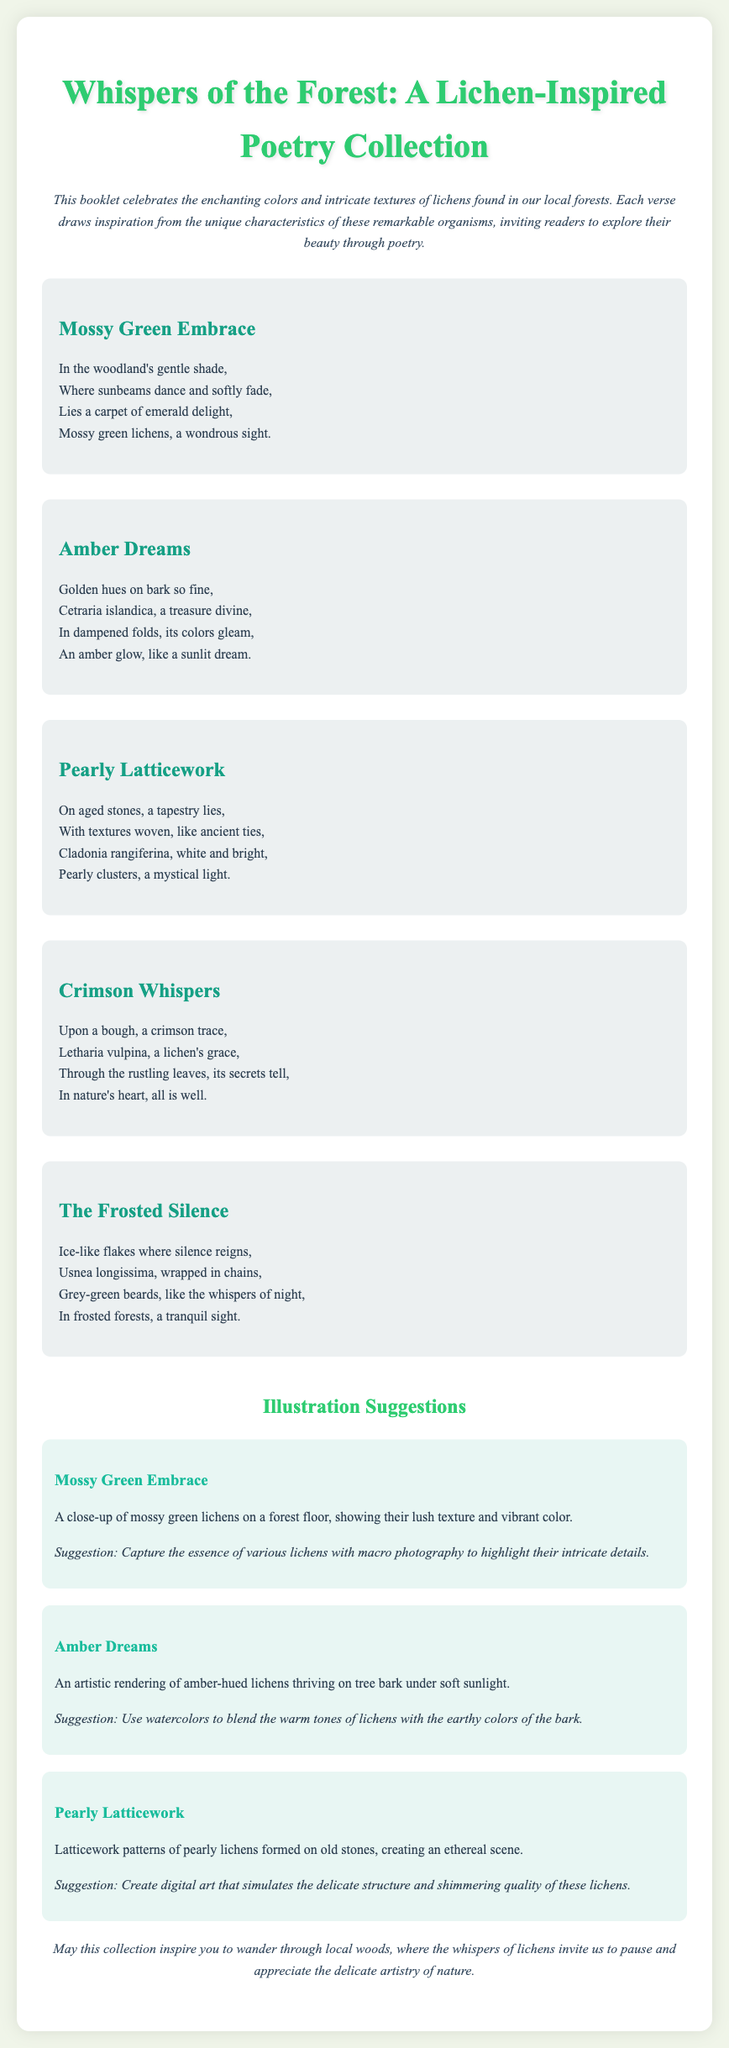What is the title of the poetry collection? The title of the poetry collection is clearly stated at the top of the document.
Answer: Whispers of the Forest: A Lichen-Inspired Poetry Collection How many poems are included in the collection? The total number of poems can be counted in the document under the poems section.
Answer: Five Which lichen is described in "Amber Dreams"? The specific lichen mentioned in the poem "Amber Dreams" is identified in the text.
Answer: Cetraria islandica What color are the lichens in "Crimson Whispers"? The color of the lichens described in "Crimson Whispers" is indicated in the poem.
Answer: Crimson What art style is suggested for the illustration of "Amber Dreams"? The suggested art style for the illustration of "Amber Dreams" is mentioned in the corresponding section.
Answer: Watercolors What is the main theme of the collection? The main theme is discussed in the introductory paragraph which conveys the essence of the document.
Answer: Colors and textures of lichens Who is the intended audience for this poetry collection? The intended audience can be inferred from the content and structure of the document.
Answer: Nature lovers and poetry enthusiasts What is the conclusion of the poetry collection about? The conclusion summarizes the message of the collection and encourages a certain action, which can be found in the text.
Answer: Inspiring to wander through local woods 